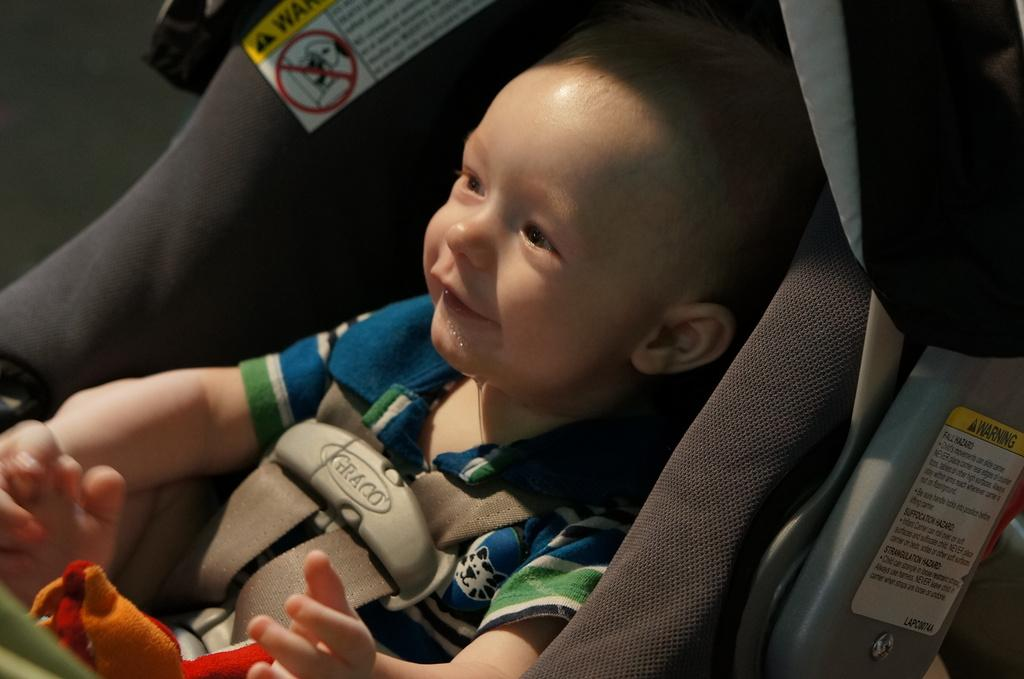What is the main subject of the image? There is a baby in the image. Where is the baby located in the image? The baby is in a stroller. What is the baby doing in the image? The baby is looking and smiling at someone. What is the baby writing in the image? There is no indication that the baby is writing anything in the image. 